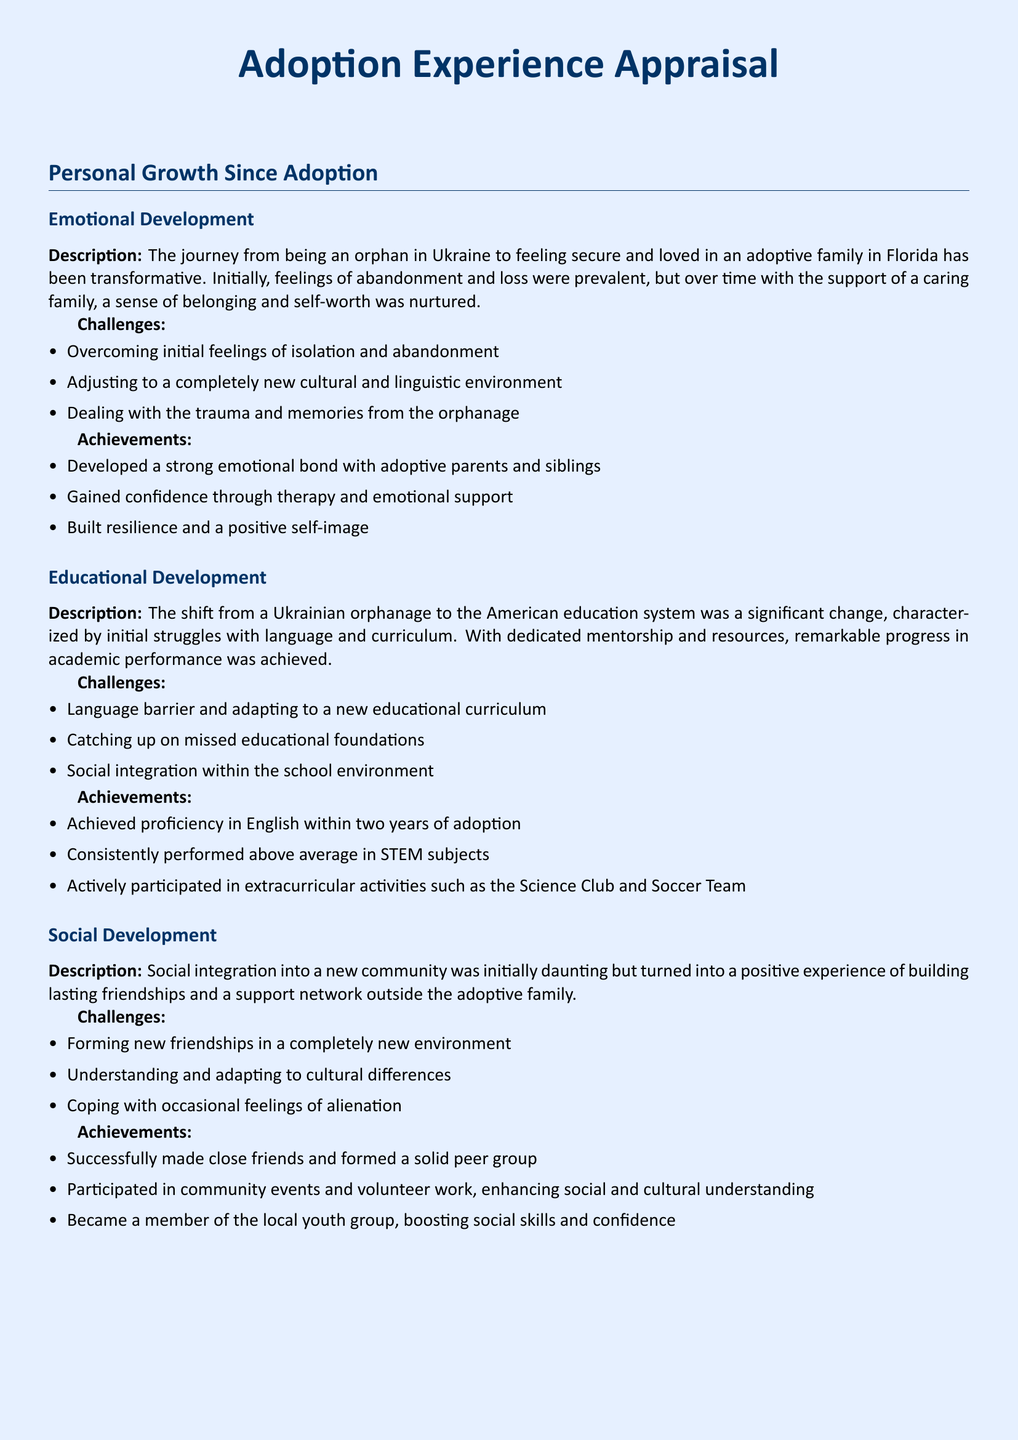What were initial feelings after adoption? The document mentions feelings of abandonment and loss as initial emotional experiences after adoption.
Answer: Abandonment and loss How long did it take to achieve proficiency in English? The document states that proficiency in English was achieved within two years of adoption.
Answer: Two years What academic subjects did the individual perform above average in? The document specifies that the individual consistently performed above average in STEM subjects.
Answer: STEM subjects What type of community involvement is mentioned? The document highlights participation in community events and volunteer work as part of social development.
Answer: Community events and volunteer work What was one major challenge in educational development? Adapting to a new educational curriculum is identified as a significant challenge in the educational development section.
Answer: Adapting to a new educational curriculum What did the individual focus on to overcome initial challenges? The text mentions gaining confidence through therapy and emotional support as a key focus.
Answer: Therapy and emotional support Which extracurricular activities did the individual participate in? The document lists participation in the Science Club and Soccer Team as extracurricular activities.
Answer: Science Club and Soccer Team How did the individual build a peer group? The document states that the individual successfully made close friends, forming a solid peer group.
Answer: Close friends What was a significant emotional achievement mentioned? The document mentions building resilience and a positive self-image as a significant emotional achievement.
Answer: Resilience and positive self-image 